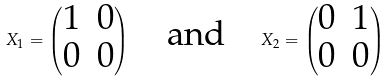Convert formula to latex. <formula><loc_0><loc_0><loc_500><loc_500>X _ { 1 } = \begin{pmatrix} 1 & 0 \\ 0 & 0 \end{pmatrix} \quad \text {and} \quad X _ { 2 } = \begin{pmatrix} 0 & 1 \\ 0 & 0 \end{pmatrix}</formula> 